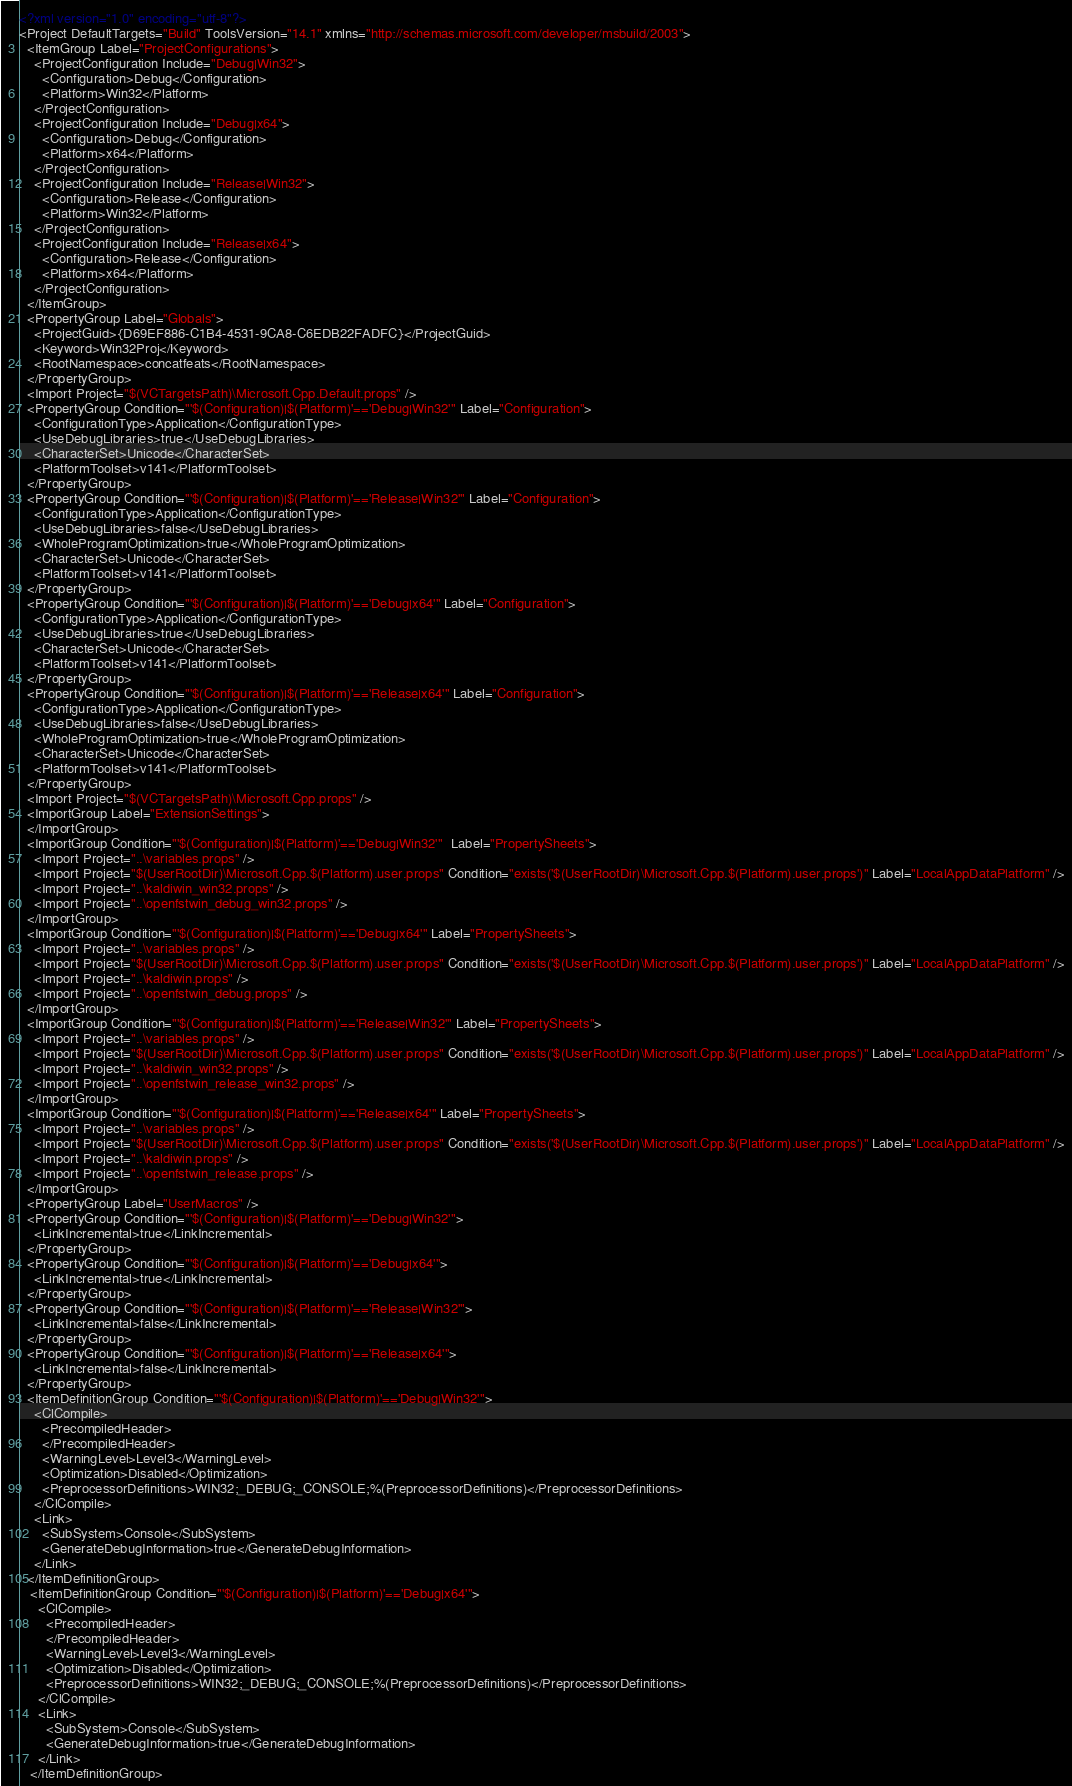<code> <loc_0><loc_0><loc_500><loc_500><_XML_><?xml version="1.0" encoding="utf-8"?>
<Project DefaultTargets="Build" ToolsVersion="14.1" xmlns="http://schemas.microsoft.com/developer/msbuild/2003">
  <ItemGroup Label="ProjectConfigurations">
    <ProjectConfiguration Include="Debug|Win32">
      <Configuration>Debug</Configuration>
      <Platform>Win32</Platform>
    </ProjectConfiguration>
    <ProjectConfiguration Include="Debug|x64">
      <Configuration>Debug</Configuration>
      <Platform>x64</Platform>
    </ProjectConfiguration>
    <ProjectConfiguration Include="Release|Win32">
      <Configuration>Release</Configuration>
      <Platform>Win32</Platform>
    </ProjectConfiguration>
    <ProjectConfiguration Include="Release|x64">
      <Configuration>Release</Configuration>
      <Platform>x64</Platform>
    </ProjectConfiguration>
  </ItemGroup>
  <PropertyGroup Label="Globals">
    <ProjectGuid>{D69EF886-C1B4-4531-9CA8-C6EDB22FADFC}</ProjectGuid>
    <Keyword>Win32Proj</Keyword>
    <RootNamespace>concatfeats</RootNamespace>
  </PropertyGroup>
  <Import Project="$(VCTargetsPath)\Microsoft.Cpp.Default.props" />
  <PropertyGroup Condition="'$(Configuration)|$(Platform)'=='Debug|Win32'" Label="Configuration">
    <ConfigurationType>Application</ConfigurationType>
    <UseDebugLibraries>true</UseDebugLibraries>
    <CharacterSet>Unicode</CharacterSet>
    <PlatformToolset>v141</PlatformToolset>
  </PropertyGroup>
  <PropertyGroup Condition="'$(Configuration)|$(Platform)'=='Release|Win32'" Label="Configuration">
    <ConfigurationType>Application</ConfigurationType>
    <UseDebugLibraries>false</UseDebugLibraries>
    <WholeProgramOptimization>true</WholeProgramOptimization>
    <CharacterSet>Unicode</CharacterSet>
    <PlatformToolset>v141</PlatformToolset>
  </PropertyGroup>
  <PropertyGroup Condition="'$(Configuration)|$(Platform)'=='Debug|x64'" Label="Configuration">
    <ConfigurationType>Application</ConfigurationType>
    <UseDebugLibraries>true</UseDebugLibraries>
    <CharacterSet>Unicode</CharacterSet>
    <PlatformToolset>v141</PlatformToolset>
  </PropertyGroup>
  <PropertyGroup Condition="'$(Configuration)|$(Platform)'=='Release|x64'" Label="Configuration">
    <ConfigurationType>Application</ConfigurationType>
    <UseDebugLibraries>false</UseDebugLibraries>
    <WholeProgramOptimization>true</WholeProgramOptimization>
    <CharacterSet>Unicode</CharacterSet>
    <PlatformToolset>v141</PlatformToolset>
  </PropertyGroup>
  <Import Project="$(VCTargetsPath)\Microsoft.Cpp.props" />
  <ImportGroup Label="ExtensionSettings">
  </ImportGroup>
  <ImportGroup Condition="'$(Configuration)|$(Platform)'=='Debug|Win32'"  Label="PropertySheets">
    <Import Project="..\variables.props" />
    <Import Project="$(UserRootDir)\Microsoft.Cpp.$(Platform).user.props" Condition="exists('$(UserRootDir)\Microsoft.Cpp.$(Platform).user.props')" Label="LocalAppDataPlatform" />
    <Import Project="..\kaldiwin_win32.props" />
    <Import Project="..\openfstwin_debug_win32.props" />
  </ImportGroup>
  <ImportGroup Condition="'$(Configuration)|$(Platform)'=='Debug|x64'" Label="PropertySheets">
    <Import Project="..\variables.props" />
    <Import Project="$(UserRootDir)\Microsoft.Cpp.$(Platform).user.props" Condition="exists('$(UserRootDir)\Microsoft.Cpp.$(Platform).user.props')" Label="LocalAppDataPlatform" />
    <Import Project="..\kaldiwin.props" />
    <Import Project="..\openfstwin_debug.props" />
  </ImportGroup>
  <ImportGroup Condition="'$(Configuration)|$(Platform)'=='Release|Win32'" Label="PropertySheets">
    <Import Project="..\variables.props" />
    <Import Project="$(UserRootDir)\Microsoft.Cpp.$(Platform).user.props" Condition="exists('$(UserRootDir)\Microsoft.Cpp.$(Platform).user.props')" Label="LocalAppDataPlatform" />
    <Import Project="..\kaldiwin_win32.props" />
    <Import Project="..\openfstwin_release_win32.props" />
  </ImportGroup>
  <ImportGroup Condition="'$(Configuration)|$(Platform)'=='Release|x64'" Label="PropertySheets">
    <Import Project="..\variables.props" />
    <Import Project="$(UserRootDir)\Microsoft.Cpp.$(Platform).user.props" Condition="exists('$(UserRootDir)\Microsoft.Cpp.$(Platform).user.props')" Label="LocalAppDataPlatform" />
    <Import Project="..\kaldiwin.props" />
    <Import Project="..\openfstwin_release.props" />
  </ImportGroup>
  <PropertyGroup Label="UserMacros" />
  <PropertyGroup Condition="'$(Configuration)|$(Platform)'=='Debug|Win32'">
    <LinkIncremental>true</LinkIncremental>
  </PropertyGroup>
  <PropertyGroup Condition="'$(Configuration)|$(Platform)'=='Debug|x64'">
    <LinkIncremental>true</LinkIncremental>
  </PropertyGroup>
  <PropertyGroup Condition="'$(Configuration)|$(Platform)'=='Release|Win32'">
    <LinkIncremental>false</LinkIncremental>
  </PropertyGroup>
  <PropertyGroup Condition="'$(Configuration)|$(Platform)'=='Release|x64'">
    <LinkIncremental>false</LinkIncremental>
  </PropertyGroup>
  <ItemDefinitionGroup Condition="'$(Configuration)|$(Platform)'=='Debug|Win32'">
    <ClCompile>
      <PrecompiledHeader>
      </PrecompiledHeader>
      <WarningLevel>Level3</WarningLevel>
      <Optimization>Disabled</Optimization>
      <PreprocessorDefinitions>WIN32;_DEBUG;_CONSOLE;%(PreprocessorDefinitions)</PreprocessorDefinitions>
    </ClCompile>
    <Link>
      <SubSystem>Console</SubSystem>
      <GenerateDebugInformation>true</GenerateDebugInformation>
    </Link>
  </ItemDefinitionGroup>
   <ItemDefinitionGroup Condition="'$(Configuration)|$(Platform)'=='Debug|x64'">
     <ClCompile>
       <PrecompiledHeader>
       </PrecompiledHeader>
       <WarningLevel>Level3</WarningLevel>
       <Optimization>Disabled</Optimization>
       <PreprocessorDefinitions>WIN32;_DEBUG;_CONSOLE;%(PreprocessorDefinitions)</PreprocessorDefinitions>
     </ClCompile>
     <Link>
       <SubSystem>Console</SubSystem>
       <GenerateDebugInformation>true</GenerateDebugInformation>
     </Link>
   </ItemDefinitionGroup></code> 